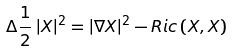<formula> <loc_0><loc_0><loc_500><loc_500>\Delta \frac { 1 } { 2 } \left | X \right | ^ { 2 } = \left | \nabla X \right | ^ { 2 } - R i c \left ( X , X \right )</formula> 